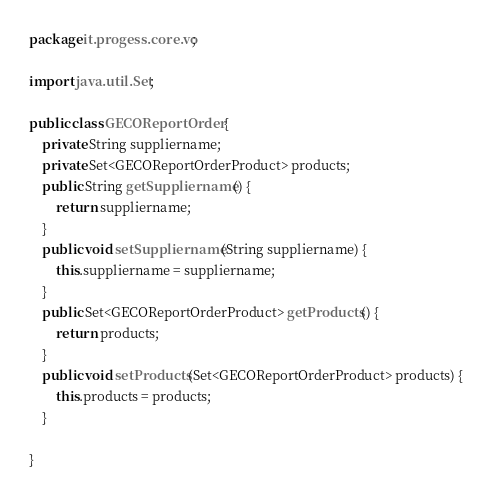Convert code to text. <code><loc_0><loc_0><loc_500><loc_500><_Java_>package it.progess.core.vo;

import java.util.Set;

public class GECOReportOrder {
	private String suppliername;
	private Set<GECOReportOrderProduct> products;
	public String getSuppliername() {
		return suppliername;
	}
	public void setSuppliername(String suppliername) {
		this.suppliername = suppliername;
	}
	public Set<GECOReportOrderProduct> getProducts() {
		return products;
	}
	public void setProducts(Set<GECOReportOrderProduct> products) {
		this.products = products;
	}
	
}
</code> 